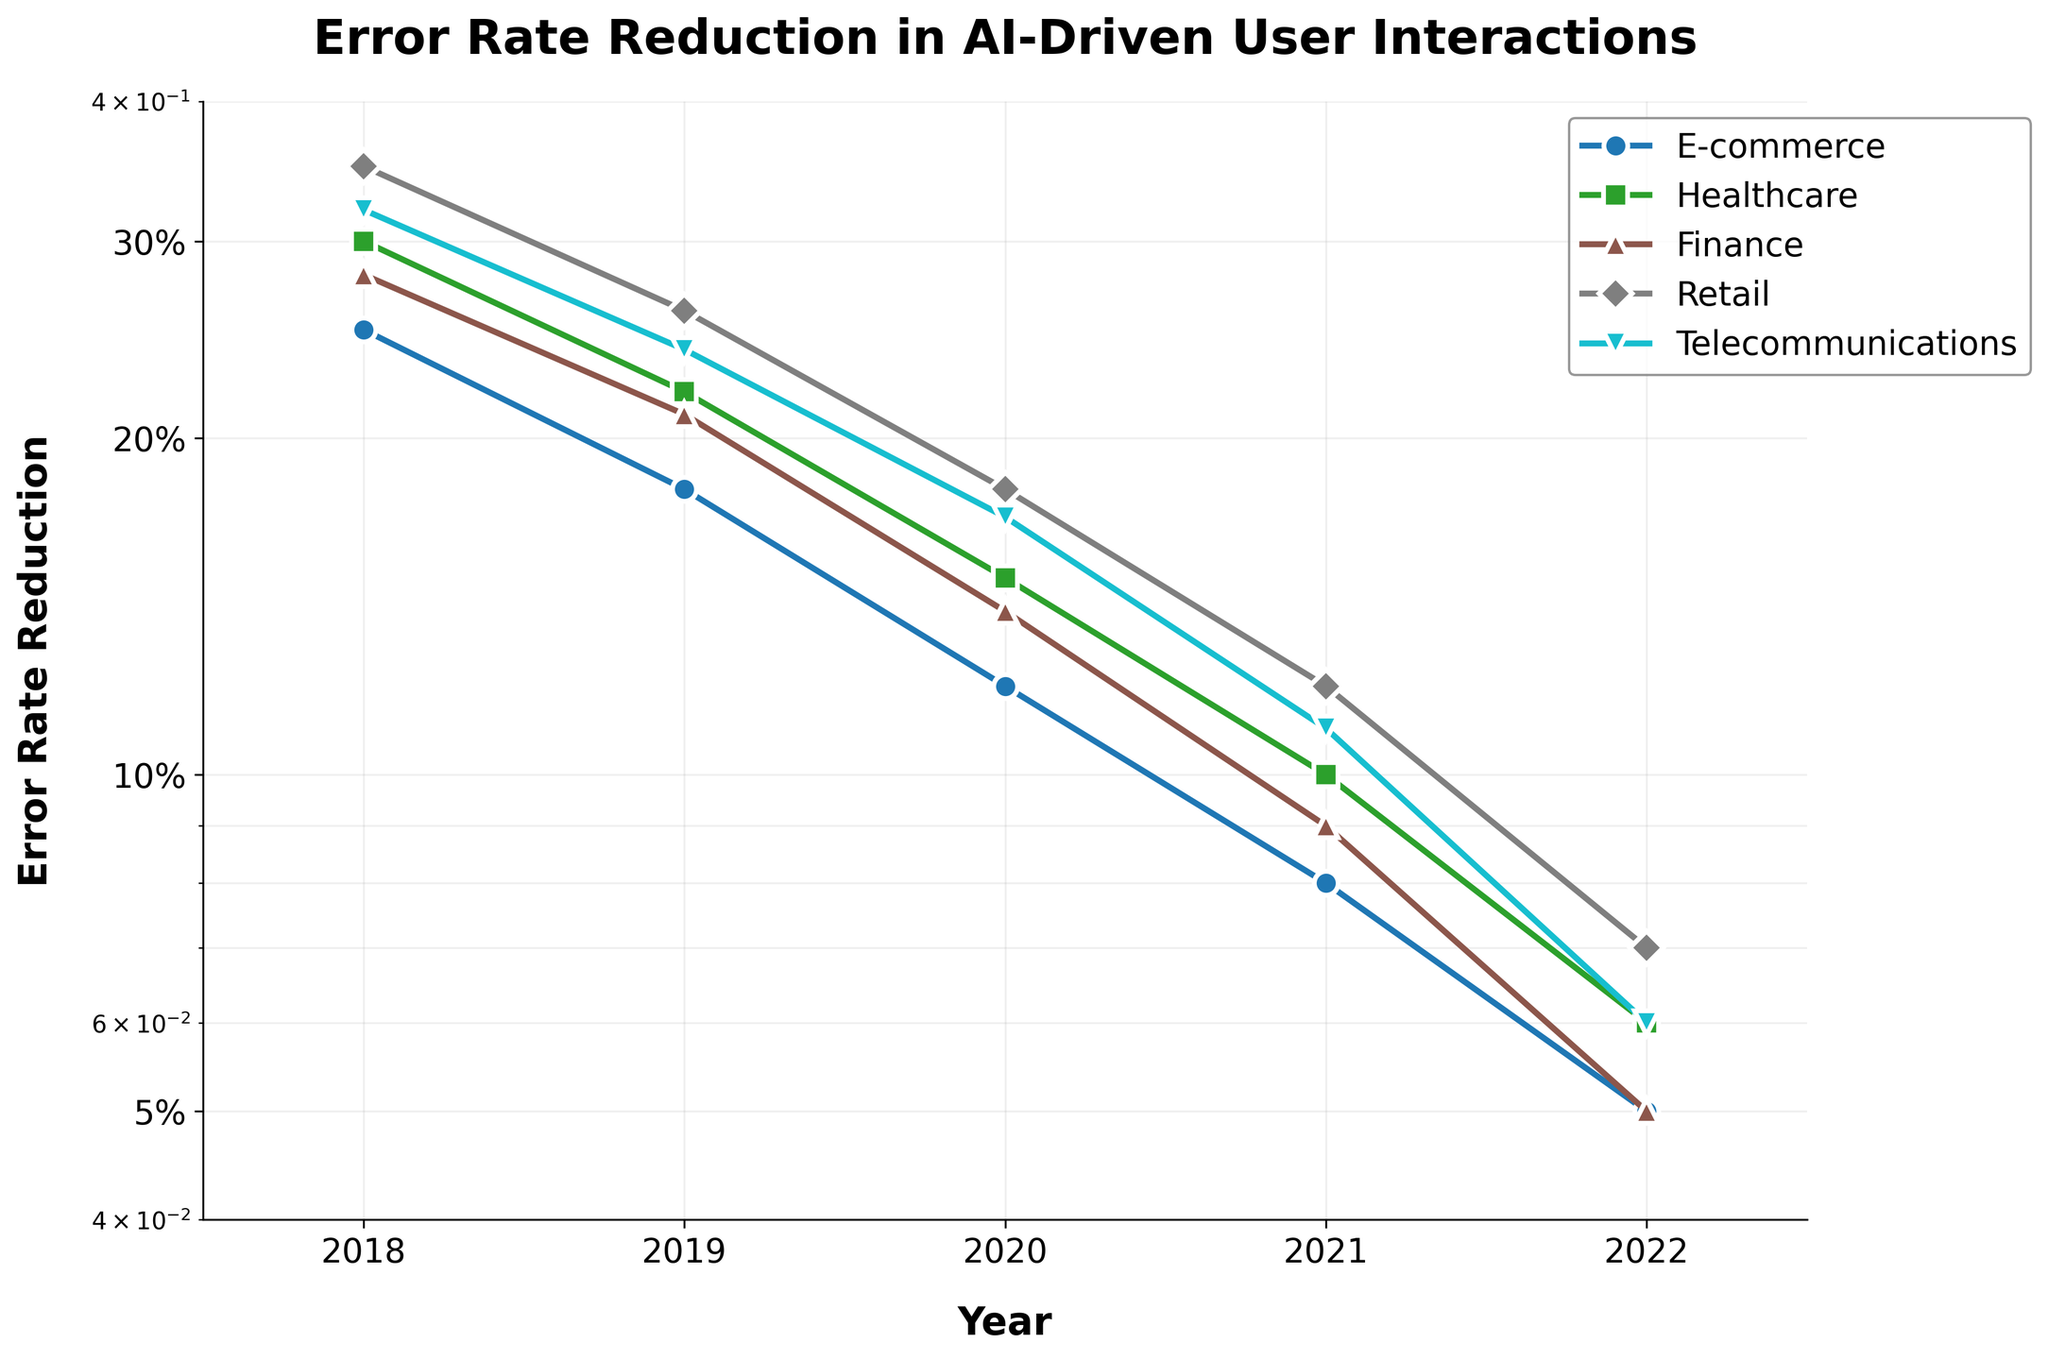what is the title of the plot? The title of the plot is located at the top and provides a concise description of what is being represented in the figure. By looking at the top center of the plot, you'll see the title "Error Rate Reduction in AI-Driven User Interactions".
Answer: Error Rate Reduction in AI-Driven User Interactions How many sectors are represented in the plot? The number of lines in the plot indicates the number of sectors. By counting the distinct colors and markers, we can identify there are five sectors: E-commerce, Healthcare, Finance, Retail, and Telecommunications.
Answer: 5 Which sector experienced the greatest reduction in error rate from 2018 to 2022? To determine the sector with the greatest error rate reduction, we look at the starting point in 2018 and the ending point in 2022 for each sector. Retail went from 0.35 in 2018 to 0.07 in 2022, which is a reduction of 0.28. Comparing these reductions: Retail (0.28), Telecommunications (0.26), Healthcare (0.24), Finance (0.23), E-commerce (0.20). Retail experienced the greatest reduction.
Answer: Retail What is the error rate reduction for Healthcare in 2020? To find this, locate the Healthcare line (identified by its distinct color and marker) and follow it to the point corresponding to 2020 on the x-axis. The y-axis value at that point represents the error rate reduction. For Healthcare in 2020, the error rate reduction is 0.15, which corresponds to 15% based on the y-axis tick labels.
Answer: 0.15 Which years showed significant improvements across all sectors? By observing the trend lines for each sector, significant improvements are indicated by steeper declines. For example, from 2018 to 2019 and 2020 to 2021, all sectors show noticeable declines in error rates.
Answer: 2018-2019, 2020-2021 What is the smallest error rate reduction recorded among all sectors and years? To find this, we need to locate the smallest point on the y-axis across all sector lines and years. The smallest error rate reduction in the plot is observed in multiple sectors, equal to 0.05 in 2022 for E-commerce and Finance.
Answer: 0.05 How does the error rate reduction in Telecommunications from 2018 to 2019 compare to that in Healthcare over the same period? To compare, locate the point for 2018 and 2019 for both sectors. Telecommunications reduced from 0.32 to 0.24, a reduction of 0.08. Healthcare reduced from 0.30 to 0.22, also a reduction of 0.08. Therefore, both sectors had an equal reduction.
Answer: Equal What trend can be observed in error rate reduction from 2018 to 2022 for all sectors? Observing the overall trend of the lines from 2018 to 2022, it is evident that the error rate reductions for all sectors continuously decrease, indicated by the downward slopes. This shows a consistent improvement in error rates over the years.
Answer: Consistent decrease 